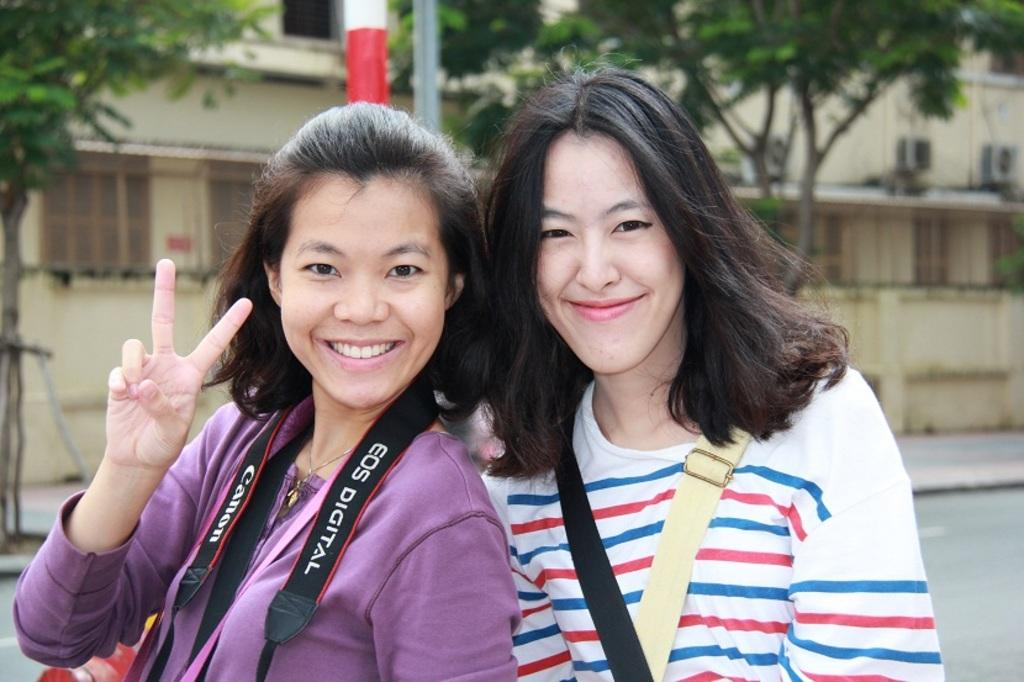How many people are in the image? There are two women in the image. What is the facial expression of the women? The women are smiling. What type of natural environment is visible in the image? There are trees at the top of the image. What type of structure is present in the image? There is a building in the middle of the image. What type of wax can be seen melting on the women's faces in the image? There is no wax present on the women's faces in the image. What is the limit of the building's height in the image? The image does not provide information about the building's height or any limits. 